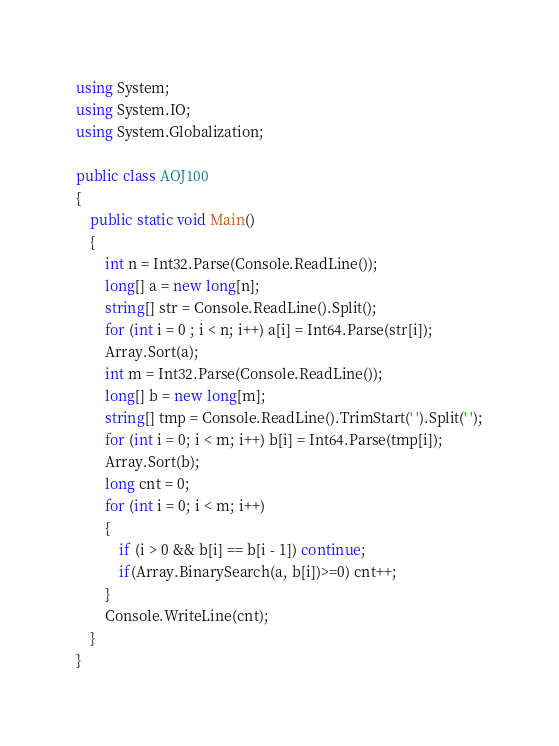Convert code to text. <code><loc_0><loc_0><loc_500><loc_500><_C#_>using System;
using System.IO;
using System.Globalization;

public class AOJ100
{
    public static void Main()
    {
        int n = Int32.Parse(Console.ReadLine());
        long[] a = new long[n];
        string[] str = Console.ReadLine().Split();
        for (int i = 0 ; i < n; i++) a[i] = Int64.Parse(str[i]);
        Array.Sort(a);
        int m = Int32.Parse(Console.ReadLine());
        long[] b = new long[m];
        string[] tmp = Console.ReadLine().TrimStart(' ').Split(' ');
        for (int i = 0; i < m; i++) b[i] = Int64.Parse(tmp[i]);
        Array.Sort(b);
        long cnt = 0;
        for (int i = 0; i < m; i++)
        {
            if (i > 0 && b[i] == b[i - 1]) continue;
            if(Array.BinarySearch(a, b[i])>=0) cnt++;
        }
        Console.WriteLine(cnt);
    }
}</code> 